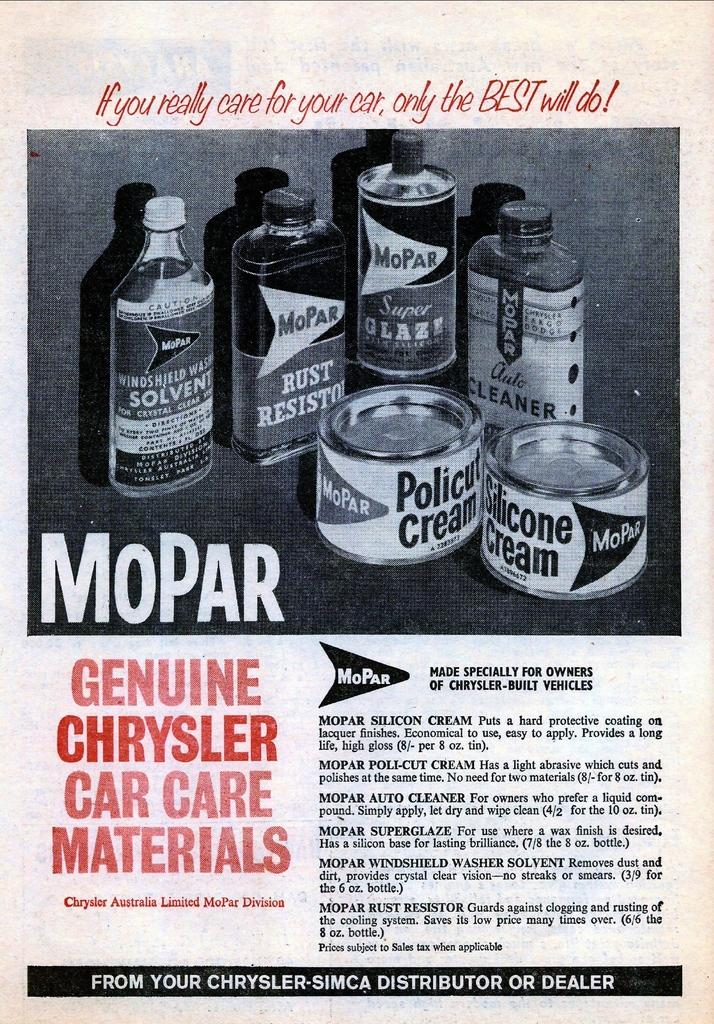<image>
Provide a brief description of the given image. A magazine add for Mopar that says Genuine Chrysler Care Care Materials. 